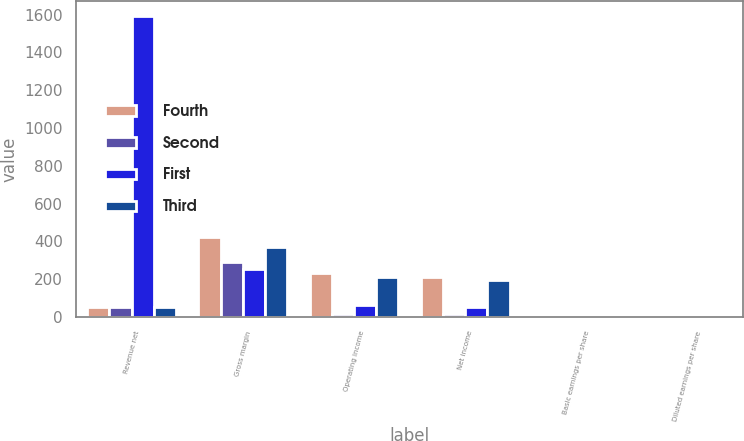Convert chart to OTSL. <chart><loc_0><loc_0><loc_500><loc_500><stacked_bar_chart><ecel><fcel>Revenue net<fcel>Gross margin<fcel>Operating income<fcel>Net income<fcel>Basic earnings per share<fcel>Diluted earnings per share<nl><fcel>Fourth<fcel>50<fcel>424<fcel>234<fcel>211<fcel>0.95<fcel>0.93<nl><fcel>Second<fcel>50<fcel>290<fcel>16<fcel>14<fcel>0.06<fcel>0.06<nl><fcel>First<fcel>1592<fcel>253<fcel>61<fcel>50<fcel>0.22<fcel>0.22<nl><fcel>Third<fcel>50<fcel>370<fcel>209<fcel>196<fcel>0.88<fcel>0.86<nl></chart> 